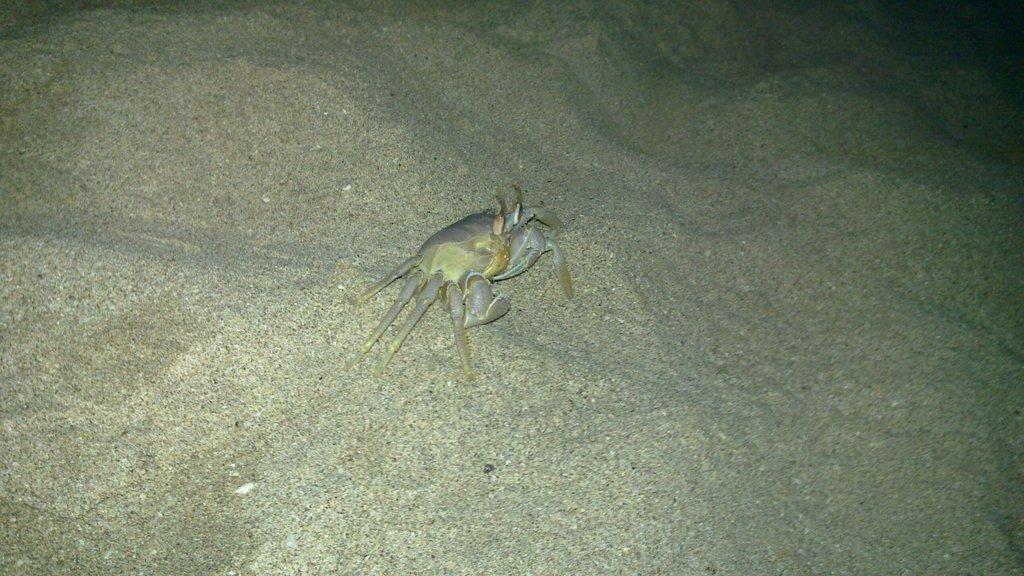What type of terrain is visible in the image? There is sand in the image. What can be seen in the middle of the image? There is an animal in the middle of the image. What type of chess piece is present in the image? There is no chess piece present in the image; it features sand and an animal. 